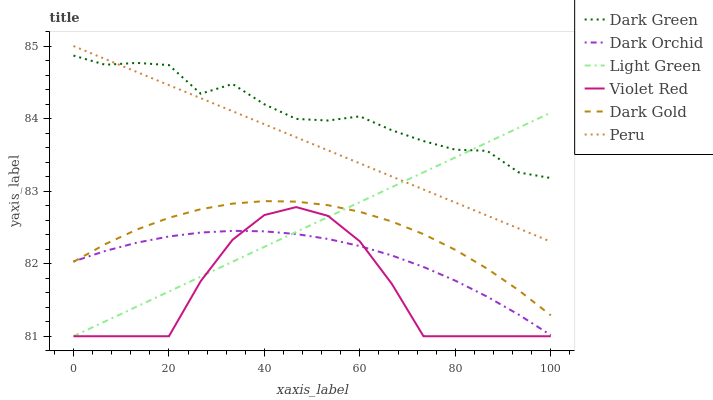Does Violet Red have the minimum area under the curve?
Answer yes or no. Yes. Does Dark Green have the maximum area under the curve?
Answer yes or no. Yes. Does Light Green have the minimum area under the curve?
Answer yes or no. No. Does Light Green have the maximum area under the curve?
Answer yes or no. No. Is Peru the smoothest?
Answer yes or no. Yes. Is Violet Red the roughest?
Answer yes or no. Yes. Is Light Green the smoothest?
Answer yes or no. No. Is Light Green the roughest?
Answer yes or no. No. Does Dark Gold have the lowest value?
Answer yes or no. No. Does Light Green have the highest value?
Answer yes or no. No. Is Dark Gold less than Dark Green?
Answer yes or no. Yes. Is Dark Gold greater than Violet Red?
Answer yes or no. Yes. Does Dark Gold intersect Dark Green?
Answer yes or no. No. 